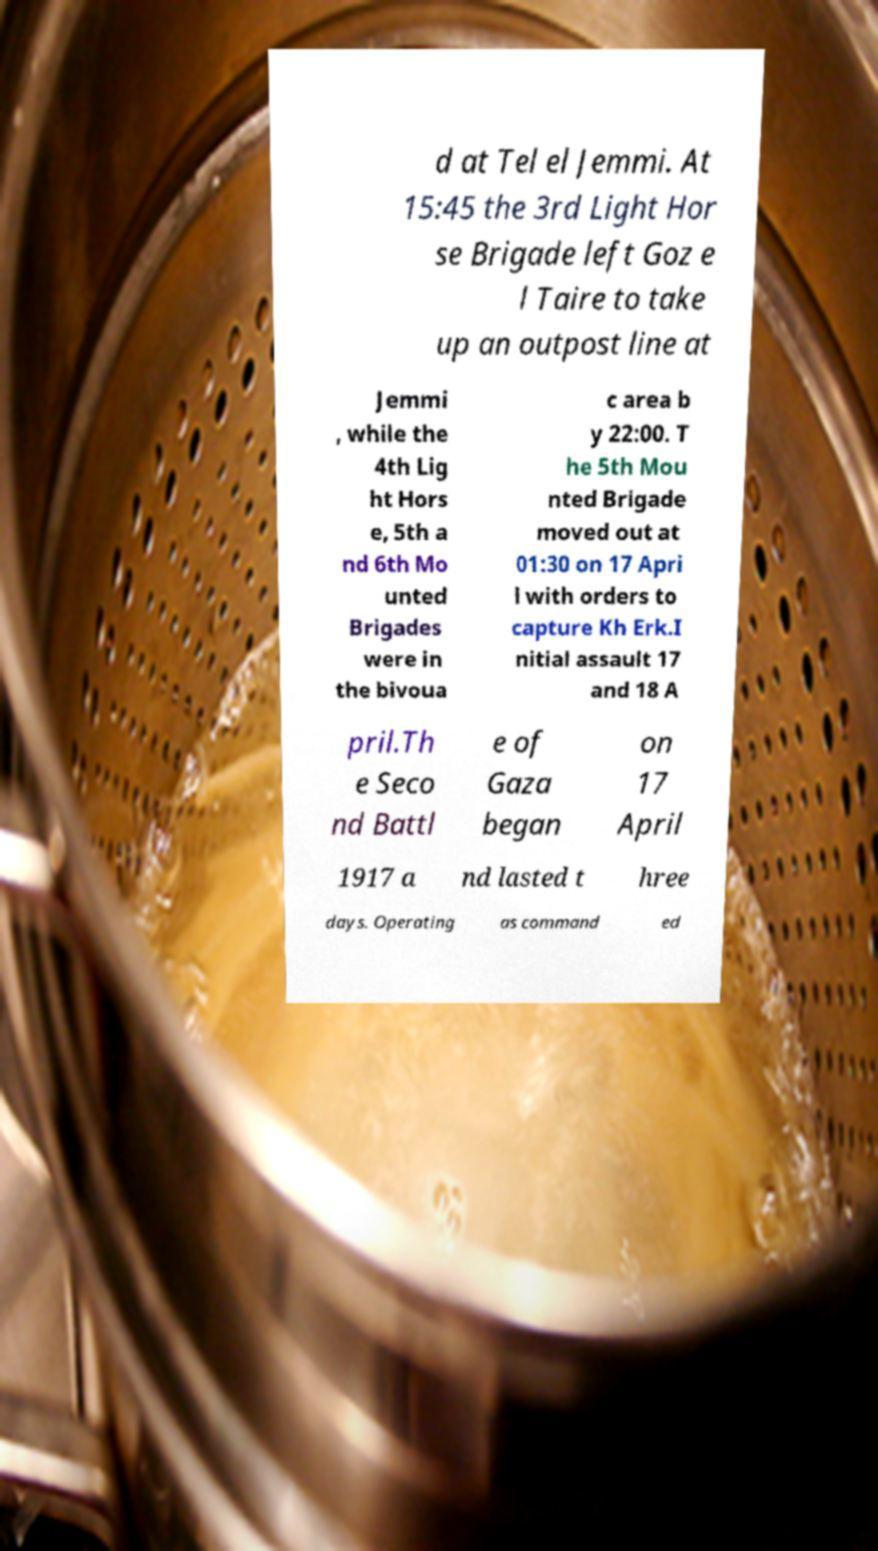Could you extract and type out the text from this image? d at Tel el Jemmi. At 15:45 the 3rd Light Hor se Brigade left Goz e l Taire to take up an outpost line at Jemmi , while the 4th Lig ht Hors e, 5th a nd 6th Mo unted Brigades were in the bivoua c area b y 22:00. T he 5th Mou nted Brigade moved out at 01:30 on 17 Apri l with orders to capture Kh Erk.I nitial assault 17 and 18 A pril.Th e Seco nd Battl e of Gaza began on 17 April 1917 a nd lasted t hree days. Operating as command ed 